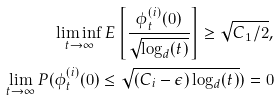Convert formula to latex. <formula><loc_0><loc_0><loc_500><loc_500>\liminf _ { t \to \infty } E \left [ \frac { \phi _ { t } ^ { ( i ) } ( 0 ) } { \sqrt { \log _ { d } ( t ) } } \right ] \geq \sqrt { C _ { 1 } / 2 } , \\ \lim _ { t \to \infty } P ( \phi _ { t } ^ { ( i ) } ( 0 ) \leq \sqrt { ( C _ { i } - \epsilon ) \log _ { d } ( t ) } ) = 0</formula> 